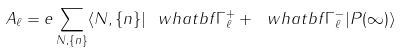Convert formula to latex. <formula><loc_0><loc_0><loc_500><loc_500>A _ { \ell } = e \sum _ { N , \{ n \} } \langle N , \{ n \} | \ w h a t b f { \Gamma } ^ { + } _ { \ell } + \ w h a t b f { \Gamma } ^ { - } _ { \ell } | P ( \infty ) \rangle</formula> 